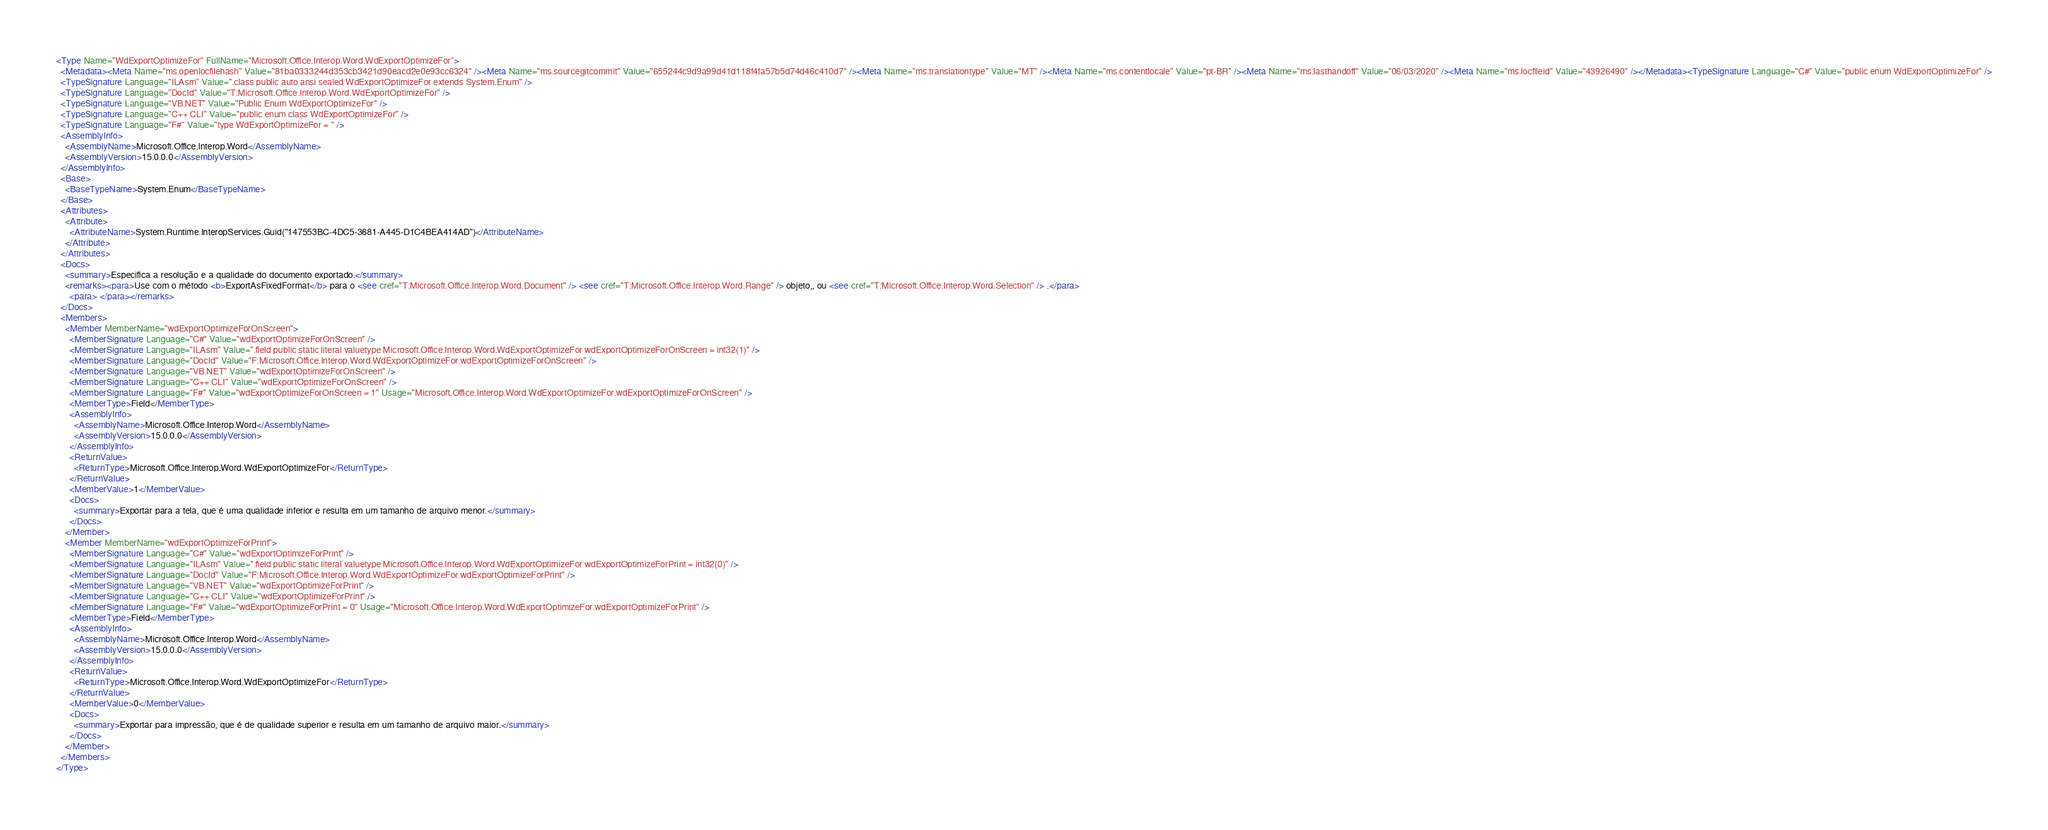<code> <loc_0><loc_0><loc_500><loc_500><_XML_><Type Name="WdExportOptimizeFor" FullName="Microsoft.Office.Interop.Word.WdExportOptimizeFor">
  <Metadata><Meta Name="ms.openlocfilehash" Value="81ba0333244d353cb3421d90eacd2e0e93cc6324" /><Meta Name="ms.sourcegitcommit" Value="655244c9d9a99d41d118f4fa57b5d74d46c410d7" /><Meta Name="ms.translationtype" Value="MT" /><Meta Name="ms.contentlocale" Value="pt-BR" /><Meta Name="ms.lasthandoff" Value="06/03/2020" /><Meta Name="ms.locfileid" Value="43926490" /></Metadata><TypeSignature Language="C#" Value="public enum WdExportOptimizeFor" />
  <TypeSignature Language="ILAsm" Value=".class public auto ansi sealed WdExportOptimizeFor extends System.Enum" />
  <TypeSignature Language="DocId" Value="T:Microsoft.Office.Interop.Word.WdExportOptimizeFor" />
  <TypeSignature Language="VB.NET" Value="Public Enum WdExportOptimizeFor" />
  <TypeSignature Language="C++ CLI" Value="public enum class WdExportOptimizeFor" />
  <TypeSignature Language="F#" Value="type WdExportOptimizeFor = " />
  <AssemblyInfo>
    <AssemblyName>Microsoft.Office.Interop.Word</AssemblyName>
    <AssemblyVersion>15.0.0.0</AssemblyVersion>
  </AssemblyInfo>
  <Base>
    <BaseTypeName>System.Enum</BaseTypeName>
  </Base>
  <Attributes>
    <Attribute>
      <AttributeName>System.Runtime.InteropServices.Guid("147553BC-4DC5-3681-A445-D1C4BEA414AD")</AttributeName>
    </Attribute>
  </Attributes>
  <Docs>
    <summary>Especifica a resolução e a qualidade do documento exportado.</summary>
    <remarks><para>Use com o método <b>ExportAsFixedFormat</b> para o <see cref="T:Microsoft.Office.Interop.Word.Document" /> <see cref="T:Microsoft.Office.Interop.Word.Range" /> objeto,, ou <see cref="T:Microsoft.Office.Interop.Word.Selection" /> .</para>
      <para> </para></remarks>
  </Docs>
  <Members>
    <Member MemberName="wdExportOptimizeForOnScreen">
      <MemberSignature Language="C#" Value="wdExportOptimizeForOnScreen" />
      <MemberSignature Language="ILAsm" Value=".field public static literal valuetype Microsoft.Office.Interop.Word.WdExportOptimizeFor wdExportOptimizeForOnScreen = int32(1)" />
      <MemberSignature Language="DocId" Value="F:Microsoft.Office.Interop.Word.WdExportOptimizeFor.wdExportOptimizeForOnScreen" />
      <MemberSignature Language="VB.NET" Value="wdExportOptimizeForOnScreen" />
      <MemberSignature Language="C++ CLI" Value="wdExportOptimizeForOnScreen" />
      <MemberSignature Language="F#" Value="wdExportOptimizeForOnScreen = 1" Usage="Microsoft.Office.Interop.Word.WdExportOptimizeFor.wdExportOptimizeForOnScreen" />
      <MemberType>Field</MemberType>
      <AssemblyInfo>
        <AssemblyName>Microsoft.Office.Interop.Word</AssemblyName>
        <AssemblyVersion>15.0.0.0</AssemblyVersion>
      </AssemblyInfo>
      <ReturnValue>
        <ReturnType>Microsoft.Office.Interop.Word.WdExportOptimizeFor</ReturnType>
      </ReturnValue>
      <MemberValue>1</MemberValue>
      <Docs>
        <summary>Exportar para a tela, que é uma qualidade inferior e resulta em um tamanho de arquivo menor.</summary>
      </Docs>
    </Member>
    <Member MemberName="wdExportOptimizeForPrint">
      <MemberSignature Language="C#" Value="wdExportOptimizeForPrint" />
      <MemberSignature Language="ILAsm" Value=".field public static literal valuetype Microsoft.Office.Interop.Word.WdExportOptimizeFor wdExportOptimizeForPrint = int32(0)" />
      <MemberSignature Language="DocId" Value="F:Microsoft.Office.Interop.Word.WdExportOptimizeFor.wdExportOptimizeForPrint" />
      <MemberSignature Language="VB.NET" Value="wdExportOptimizeForPrint" />
      <MemberSignature Language="C++ CLI" Value="wdExportOptimizeForPrint" />
      <MemberSignature Language="F#" Value="wdExportOptimizeForPrint = 0" Usage="Microsoft.Office.Interop.Word.WdExportOptimizeFor.wdExportOptimizeForPrint" />
      <MemberType>Field</MemberType>
      <AssemblyInfo>
        <AssemblyName>Microsoft.Office.Interop.Word</AssemblyName>
        <AssemblyVersion>15.0.0.0</AssemblyVersion>
      </AssemblyInfo>
      <ReturnValue>
        <ReturnType>Microsoft.Office.Interop.Word.WdExportOptimizeFor</ReturnType>
      </ReturnValue>
      <MemberValue>0</MemberValue>
      <Docs>
        <summary>Exportar para impressão, que é de qualidade superior e resulta em um tamanho de arquivo maior.</summary>
      </Docs>
    </Member>
  </Members>
</Type>
</code> 